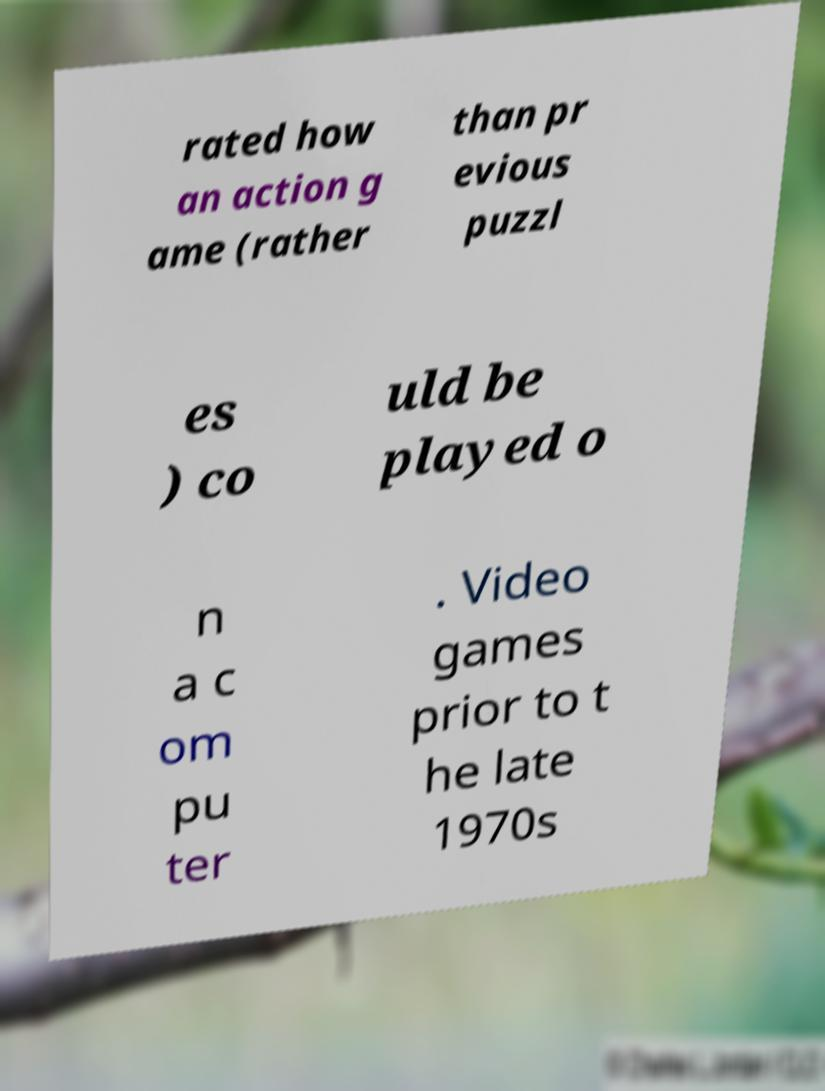Can you accurately transcribe the text from the provided image for me? rated how an action g ame (rather than pr evious puzzl es ) co uld be played o n a c om pu ter . Video games prior to t he late 1970s 